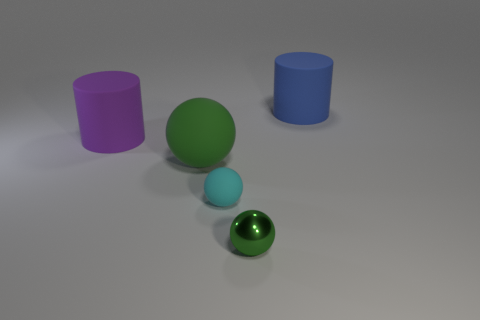What is the shape of the large purple object that is made of the same material as the large blue cylinder?
Ensure brevity in your answer.  Cylinder. Is the tiny matte thing the same color as the metal thing?
Keep it short and to the point. No. The other ball that is the same color as the tiny metallic ball is what size?
Your answer should be very brief. Large. There is a green rubber thing that is the same size as the purple rubber thing; what shape is it?
Offer a very short reply. Sphere. There is a small matte thing; are there any large matte objects to the right of it?
Your answer should be compact. Yes. There is a green object that is in front of the cyan rubber sphere; is there a cyan matte object that is on the left side of it?
Provide a succinct answer. Yes. Is the number of matte cylinders in front of the big blue rubber cylinder less than the number of big rubber objects that are behind the big matte sphere?
Offer a very short reply. Yes. What is the shape of the tiny rubber object?
Keep it short and to the point. Sphere. There is a small object in front of the small matte thing; what is its material?
Ensure brevity in your answer.  Metal. What is the size of the cylinder left of the matte cylinder that is behind the cylinder that is on the left side of the large blue thing?
Your answer should be compact. Large. 